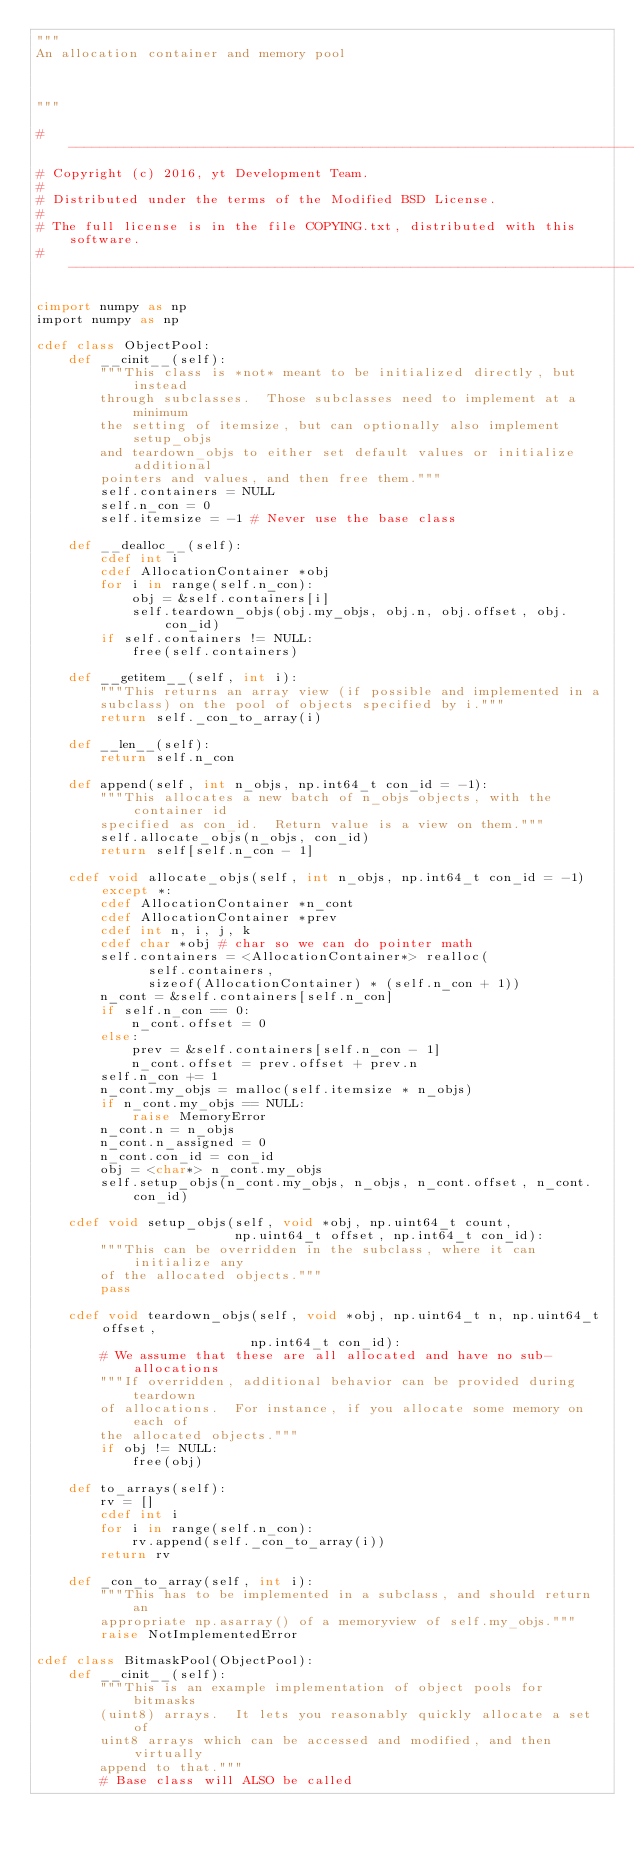<code> <loc_0><loc_0><loc_500><loc_500><_Cython_>"""
An allocation container and memory pool



"""

#-----------------------------------------------------------------------------
# Copyright (c) 2016, yt Development Team.
#
# Distributed under the terms of the Modified BSD License.
#
# The full license is in the file COPYING.txt, distributed with this software.
#-----------------------------------------------------------------------------

cimport numpy as np
import numpy as np

cdef class ObjectPool:
    def __cinit__(self):
        """This class is *not* meant to be initialized directly, but instead
        through subclasses.  Those subclasses need to implement at a minimum
        the setting of itemsize, but can optionally also implement setup_objs
        and teardown_objs to either set default values or initialize additional
        pointers and values, and then free them."""
        self.containers = NULL
        self.n_con = 0
        self.itemsize = -1 # Never use the base class

    def __dealloc__(self):
        cdef int i
        cdef AllocationContainer *obj
        for i in range(self.n_con):
            obj = &self.containers[i]
            self.teardown_objs(obj.my_objs, obj.n, obj.offset, obj.con_id)
        if self.containers != NULL:
            free(self.containers)

    def __getitem__(self, int i):
        """This returns an array view (if possible and implemented in a
        subclass) on the pool of objects specified by i."""
        return self._con_to_array(i)

    def __len__(self):
        return self.n_con

    def append(self, int n_objs, np.int64_t con_id = -1):
        """This allocates a new batch of n_objs objects, with the container id
        specified as con_id.  Return value is a view on them."""
        self.allocate_objs(n_objs, con_id)
        return self[self.n_con - 1]
        
    cdef void allocate_objs(self, int n_objs, np.int64_t con_id = -1) except *:
        cdef AllocationContainer *n_cont
        cdef AllocationContainer *prev
        cdef int n, i, j, k
        cdef char *obj # char so we can do pointer math
        self.containers = <AllocationContainer*> realloc(
              self.containers, 
              sizeof(AllocationContainer) * (self.n_con + 1))
        n_cont = &self.containers[self.n_con]
        if self.n_con == 0:
            n_cont.offset = 0
        else:
            prev = &self.containers[self.n_con - 1]
            n_cont.offset = prev.offset + prev.n
        self.n_con += 1
        n_cont.my_objs = malloc(self.itemsize * n_objs)
        if n_cont.my_objs == NULL:
            raise MemoryError
        n_cont.n = n_objs
        n_cont.n_assigned = 0
        n_cont.con_id = con_id
        obj = <char*> n_cont.my_objs
        self.setup_objs(n_cont.my_objs, n_objs, n_cont.offset, n_cont.con_id)

    cdef void setup_objs(self, void *obj, np.uint64_t count,
                         np.uint64_t offset, np.int64_t con_id):
        """This can be overridden in the subclass, where it can initialize any
        of the allocated objects."""
        pass

    cdef void teardown_objs(self, void *obj, np.uint64_t n, np.uint64_t offset,
                           np.int64_t con_id):
        # We assume that these are all allocated and have no sub-allocations
        """If overridden, additional behavior can be provided during teardown
        of allocations.  For instance, if you allocate some memory on each of
        the allocated objects."""
        if obj != NULL:
            free(obj)

    def to_arrays(self):
        rv = []
        cdef int i
        for i in range(self.n_con):
            rv.append(self._con_to_array(i))
        return rv

    def _con_to_array(self, int i):
        """This has to be implemented in a subclass, and should return an
        appropriate np.asarray() of a memoryview of self.my_objs."""
        raise NotImplementedError

cdef class BitmaskPool(ObjectPool):
    def __cinit__(self):
        """This is an example implementation of object pools for bitmasks
        (uint8) arrays.  It lets you reasonably quickly allocate a set of
        uint8 arrays which can be accessed and modified, and then virtually
        append to that."""
        # Base class will ALSO be called</code> 